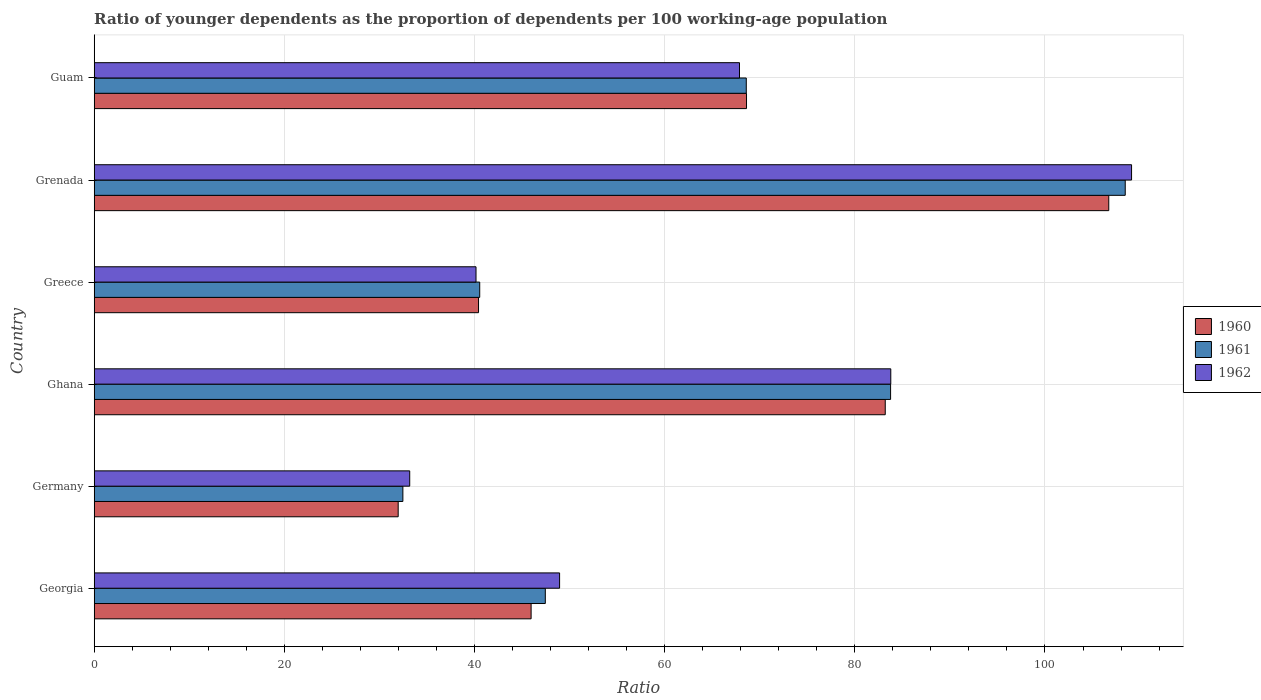How many different coloured bars are there?
Your response must be concise. 3. How many groups of bars are there?
Your answer should be very brief. 6. What is the label of the 6th group of bars from the top?
Offer a terse response. Georgia. What is the age dependency ratio(young) in 1960 in Georgia?
Your response must be concise. 45.95. Across all countries, what is the maximum age dependency ratio(young) in 1961?
Keep it short and to the point. 108.44. Across all countries, what is the minimum age dependency ratio(young) in 1961?
Your response must be concise. 32.47. In which country was the age dependency ratio(young) in 1960 maximum?
Offer a terse response. Grenada. In which country was the age dependency ratio(young) in 1960 minimum?
Your answer should be very brief. Germany. What is the total age dependency ratio(young) in 1962 in the graph?
Your response must be concise. 383.05. What is the difference between the age dependency ratio(young) in 1962 in Ghana and that in Guam?
Ensure brevity in your answer.  15.91. What is the difference between the age dependency ratio(young) in 1962 in Ghana and the age dependency ratio(young) in 1961 in Guam?
Ensure brevity in your answer.  15.2. What is the average age dependency ratio(young) in 1961 per country?
Ensure brevity in your answer.  63.54. What is the difference between the age dependency ratio(young) in 1960 and age dependency ratio(young) in 1961 in Germany?
Give a very brief answer. -0.49. In how many countries, is the age dependency ratio(young) in 1962 greater than 64 ?
Ensure brevity in your answer.  3. What is the ratio of the age dependency ratio(young) in 1961 in Greece to that in Guam?
Your response must be concise. 0.59. Is the age dependency ratio(young) in 1961 in Ghana less than that in Grenada?
Offer a very short reply. Yes. What is the difference between the highest and the second highest age dependency ratio(young) in 1962?
Make the answer very short. 25.32. What is the difference between the highest and the lowest age dependency ratio(young) in 1960?
Offer a terse response. 74.74. Is the sum of the age dependency ratio(young) in 1961 in Georgia and Ghana greater than the maximum age dependency ratio(young) in 1960 across all countries?
Provide a succinct answer. Yes. What does the 3rd bar from the top in Grenada represents?
Keep it short and to the point. 1960. What does the 2nd bar from the bottom in Grenada represents?
Ensure brevity in your answer.  1961. Are all the bars in the graph horizontal?
Give a very brief answer. Yes. How many countries are there in the graph?
Your answer should be compact. 6. Are the values on the major ticks of X-axis written in scientific E-notation?
Offer a terse response. No. Does the graph contain any zero values?
Your answer should be very brief. No. Does the graph contain grids?
Keep it short and to the point. Yes. Where does the legend appear in the graph?
Offer a terse response. Center right. How are the legend labels stacked?
Provide a short and direct response. Vertical. What is the title of the graph?
Make the answer very short. Ratio of younger dependents as the proportion of dependents per 100 working-age population. What is the label or title of the X-axis?
Provide a succinct answer. Ratio. What is the label or title of the Y-axis?
Provide a succinct answer. Country. What is the Ratio of 1960 in Georgia?
Offer a terse response. 45.95. What is the Ratio of 1961 in Georgia?
Give a very brief answer. 47.45. What is the Ratio in 1962 in Georgia?
Your answer should be compact. 48.95. What is the Ratio of 1960 in Germany?
Give a very brief answer. 31.97. What is the Ratio in 1961 in Germany?
Ensure brevity in your answer.  32.47. What is the Ratio of 1962 in Germany?
Give a very brief answer. 33.19. What is the Ratio in 1960 in Ghana?
Your response must be concise. 83.2. What is the Ratio of 1961 in Ghana?
Ensure brevity in your answer.  83.76. What is the Ratio of 1962 in Ghana?
Give a very brief answer. 83.78. What is the Ratio in 1960 in Greece?
Give a very brief answer. 40.42. What is the Ratio of 1961 in Greece?
Offer a very short reply. 40.55. What is the Ratio in 1962 in Greece?
Provide a short and direct response. 40.16. What is the Ratio in 1960 in Grenada?
Your response must be concise. 106.71. What is the Ratio of 1961 in Grenada?
Ensure brevity in your answer.  108.44. What is the Ratio in 1962 in Grenada?
Your answer should be compact. 109.11. What is the Ratio of 1960 in Guam?
Ensure brevity in your answer.  68.61. What is the Ratio in 1961 in Guam?
Give a very brief answer. 68.58. What is the Ratio of 1962 in Guam?
Provide a short and direct response. 67.87. Across all countries, what is the maximum Ratio in 1960?
Provide a succinct answer. 106.71. Across all countries, what is the maximum Ratio in 1961?
Give a very brief answer. 108.44. Across all countries, what is the maximum Ratio in 1962?
Offer a very short reply. 109.11. Across all countries, what is the minimum Ratio in 1960?
Your answer should be compact. 31.97. Across all countries, what is the minimum Ratio in 1961?
Offer a terse response. 32.47. Across all countries, what is the minimum Ratio in 1962?
Make the answer very short. 33.19. What is the total Ratio of 1960 in the graph?
Make the answer very short. 376.86. What is the total Ratio in 1961 in the graph?
Give a very brief answer. 381.24. What is the total Ratio of 1962 in the graph?
Offer a terse response. 383.05. What is the difference between the Ratio in 1960 in Georgia and that in Germany?
Ensure brevity in your answer.  13.98. What is the difference between the Ratio in 1961 in Georgia and that in Germany?
Offer a very short reply. 14.98. What is the difference between the Ratio in 1962 in Georgia and that in Germany?
Provide a succinct answer. 15.76. What is the difference between the Ratio in 1960 in Georgia and that in Ghana?
Make the answer very short. -37.25. What is the difference between the Ratio of 1961 in Georgia and that in Ghana?
Offer a very short reply. -36.32. What is the difference between the Ratio of 1962 in Georgia and that in Ghana?
Provide a short and direct response. -34.83. What is the difference between the Ratio of 1960 in Georgia and that in Greece?
Give a very brief answer. 5.53. What is the difference between the Ratio in 1961 in Georgia and that in Greece?
Your answer should be compact. 6.9. What is the difference between the Ratio of 1962 in Georgia and that in Greece?
Give a very brief answer. 8.79. What is the difference between the Ratio in 1960 in Georgia and that in Grenada?
Offer a very short reply. -60.76. What is the difference between the Ratio of 1961 in Georgia and that in Grenada?
Offer a very short reply. -60.99. What is the difference between the Ratio of 1962 in Georgia and that in Grenada?
Provide a short and direct response. -60.16. What is the difference between the Ratio of 1960 in Georgia and that in Guam?
Keep it short and to the point. -22.66. What is the difference between the Ratio of 1961 in Georgia and that in Guam?
Offer a terse response. -21.14. What is the difference between the Ratio of 1962 in Georgia and that in Guam?
Provide a short and direct response. -18.92. What is the difference between the Ratio in 1960 in Germany and that in Ghana?
Keep it short and to the point. -51.23. What is the difference between the Ratio of 1961 in Germany and that in Ghana?
Offer a very short reply. -51.3. What is the difference between the Ratio in 1962 in Germany and that in Ghana?
Keep it short and to the point. -50.6. What is the difference between the Ratio in 1960 in Germany and that in Greece?
Your answer should be compact. -8.45. What is the difference between the Ratio of 1961 in Germany and that in Greece?
Offer a terse response. -8.08. What is the difference between the Ratio in 1962 in Germany and that in Greece?
Give a very brief answer. -6.97. What is the difference between the Ratio of 1960 in Germany and that in Grenada?
Ensure brevity in your answer.  -74.74. What is the difference between the Ratio of 1961 in Germany and that in Grenada?
Your answer should be compact. -75.97. What is the difference between the Ratio in 1962 in Germany and that in Grenada?
Offer a terse response. -75.92. What is the difference between the Ratio in 1960 in Germany and that in Guam?
Your answer should be very brief. -36.64. What is the difference between the Ratio of 1961 in Germany and that in Guam?
Keep it short and to the point. -36.12. What is the difference between the Ratio of 1962 in Germany and that in Guam?
Keep it short and to the point. -34.69. What is the difference between the Ratio of 1960 in Ghana and that in Greece?
Keep it short and to the point. 42.78. What is the difference between the Ratio of 1961 in Ghana and that in Greece?
Make the answer very short. 43.21. What is the difference between the Ratio of 1962 in Ghana and that in Greece?
Your response must be concise. 43.62. What is the difference between the Ratio of 1960 in Ghana and that in Grenada?
Keep it short and to the point. -23.51. What is the difference between the Ratio in 1961 in Ghana and that in Grenada?
Make the answer very short. -24.68. What is the difference between the Ratio in 1962 in Ghana and that in Grenada?
Offer a terse response. -25.32. What is the difference between the Ratio in 1960 in Ghana and that in Guam?
Your answer should be compact. 14.59. What is the difference between the Ratio in 1961 in Ghana and that in Guam?
Keep it short and to the point. 15.18. What is the difference between the Ratio of 1962 in Ghana and that in Guam?
Keep it short and to the point. 15.91. What is the difference between the Ratio of 1960 in Greece and that in Grenada?
Provide a short and direct response. -66.29. What is the difference between the Ratio in 1961 in Greece and that in Grenada?
Your response must be concise. -67.89. What is the difference between the Ratio of 1962 in Greece and that in Grenada?
Provide a succinct answer. -68.95. What is the difference between the Ratio of 1960 in Greece and that in Guam?
Your answer should be very brief. -28.18. What is the difference between the Ratio of 1961 in Greece and that in Guam?
Your answer should be very brief. -28.04. What is the difference between the Ratio of 1962 in Greece and that in Guam?
Give a very brief answer. -27.71. What is the difference between the Ratio of 1960 in Grenada and that in Guam?
Make the answer very short. 38.1. What is the difference between the Ratio of 1961 in Grenada and that in Guam?
Provide a succinct answer. 39.86. What is the difference between the Ratio of 1962 in Grenada and that in Guam?
Offer a terse response. 41.23. What is the difference between the Ratio in 1960 in Georgia and the Ratio in 1961 in Germany?
Offer a very short reply. 13.49. What is the difference between the Ratio of 1960 in Georgia and the Ratio of 1962 in Germany?
Give a very brief answer. 12.77. What is the difference between the Ratio in 1961 in Georgia and the Ratio in 1962 in Germany?
Your answer should be very brief. 14.26. What is the difference between the Ratio of 1960 in Georgia and the Ratio of 1961 in Ghana?
Your response must be concise. -37.81. What is the difference between the Ratio in 1960 in Georgia and the Ratio in 1962 in Ghana?
Give a very brief answer. -37.83. What is the difference between the Ratio in 1961 in Georgia and the Ratio in 1962 in Ghana?
Provide a succinct answer. -36.34. What is the difference between the Ratio of 1960 in Georgia and the Ratio of 1961 in Greece?
Your answer should be compact. 5.41. What is the difference between the Ratio of 1960 in Georgia and the Ratio of 1962 in Greece?
Ensure brevity in your answer.  5.79. What is the difference between the Ratio in 1961 in Georgia and the Ratio in 1962 in Greece?
Provide a short and direct response. 7.29. What is the difference between the Ratio in 1960 in Georgia and the Ratio in 1961 in Grenada?
Your answer should be compact. -62.49. What is the difference between the Ratio in 1960 in Georgia and the Ratio in 1962 in Grenada?
Offer a terse response. -63.15. What is the difference between the Ratio in 1961 in Georgia and the Ratio in 1962 in Grenada?
Your answer should be compact. -61.66. What is the difference between the Ratio of 1960 in Georgia and the Ratio of 1961 in Guam?
Your answer should be very brief. -22.63. What is the difference between the Ratio in 1960 in Georgia and the Ratio in 1962 in Guam?
Provide a succinct answer. -21.92. What is the difference between the Ratio of 1961 in Georgia and the Ratio of 1962 in Guam?
Provide a succinct answer. -20.42. What is the difference between the Ratio in 1960 in Germany and the Ratio in 1961 in Ghana?
Provide a short and direct response. -51.79. What is the difference between the Ratio of 1960 in Germany and the Ratio of 1962 in Ghana?
Your answer should be very brief. -51.81. What is the difference between the Ratio in 1961 in Germany and the Ratio in 1962 in Ghana?
Ensure brevity in your answer.  -51.32. What is the difference between the Ratio of 1960 in Germany and the Ratio of 1961 in Greece?
Provide a short and direct response. -8.57. What is the difference between the Ratio of 1960 in Germany and the Ratio of 1962 in Greece?
Offer a terse response. -8.19. What is the difference between the Ratio in 1961 in Germany and the Ratio in 1962 in Greece?
Offer a very short reply. -7.69. What is the difference between the Ratio in 1960 in Germany and the Ratio in 1961 in Grenada?
Provide a succinct answer. -76.47. What is the difference between the Ratio of 1960 in Germany and the Ratio of 1962 in Grenada?
Your response must be concise. -77.13. What is the difference between the Ratio of 1961 in Germany and the Ratio of 1962 in Grenada?
Make the answer very short. -76.64. What is the difference between the Ratio in 1960 in Germany and the Ratio in 1961 in Guam?
Provide a succinct answer. -36.61. What is the difference between the Ratio of 1960 in Germany and the Ratio of 1962 in Guam?
Your response must be concise. -35.9. What is the difference between the Ratio of 1961 in Germany and the Ratio of 1962 in Guam?
Your response must be concise. -35.41. What is the difference between the Ratio in 1960 in Ghana and the Ratio in 1961 in Greece?
Ensure brevity in your answer.  42.65. What is the difference between the Ratio in 1960 in Ghana and the Ratio in 1962 in Greece?
Your answer should be compact. 43.04. What is the difference between the Ratio of 1961 in Ghana and the Ratio of 1962 in Greece?
Keep it short and to the point. 43.6. What is the difference between the Ratio in 1960 in Ghana and the Ratio in 1961 in Grenada?
Make the answer very short. -25.24. What is the difference between the Ratio of 1960 in Ghana and the Ratio of 1962 in Grenada?
Your answer should be compact. -25.91. What is the difference between the Ratio of 1961 in Ghana and the Ratio of 1962 in Grenada?
Offer a very short reply. -25.34. What is the difference between the Ratio in 1960 in Ghana and the Ratio in 1961 in Guam?
Provide a succinct answer. 14.62. What is the difference between the Ratio of 1960 in Ghana and the Ratio of 1962 in Guam?
Your response must be concise. 15.33. What is the difference between the Ratio of 1961 in Ghana and the Ratio of 1962 in Guam?
Your answer should be very brief. 15.89. What is the difference between the Ratio of 1960 in Greece and the Ratio of 1961 in Grenada?
Provide a short and direct response. -68.02. What is the difference between the Ratio of 1960 in Greece and the Ratio of 1962 in Grenada?
Your answer should be compact. -68.68. What is the difference between the Ratio of 1961 in Greece and the Ratio of 1962 in Grenada?
Your response must be concise. -68.56. What is the difference between the Ratio in 1960 in Greece and the Ratio in 1961 in Guam?
Give a very brief answer. -28.16. What is the difference between the Ratio of 1960 in Greece and the Ratio of 1962 in Guam?
Offer a terse response. -27.45. What is the difference between the Ratio in 1961 in Greece and the Ratio in 1962 in Guam?
Ensure brevity in your answer.  -27.32. What is the difference between the Ratio of 1960 in Grenada and the Ratio of 1961 in Guam?
Your answer should be very brief. 38.13. What is the difference between the Ratio in 1960 in Grenada and the Ratio in 1962 in Guam?
Your answer should be very brief. 38.84. What is the difference between the Ratio in 1961 in Grenada and the Ratio in 1962 in Guam?
Make the answer very short. 40.57. What is the average Ratio of 1960 per country?
Ensure brevity in your answer.  62.81. What is the average Ratio in 1961 per country?
Your answer should be compact. 63.54. What is the average Ratio in 1962 per country?
Offer a very short reply. 63.84. What is the difference between the Ratio of 1960 and Ratio of 1961 in Georgia?
Your answer should be compact. -1.49. What is the difference between the Ratio of 1960 and Ratio of 1962 in Georgia?
Your answer should be very brief. -3. What is the difference between the Ratio of 1961 and Ratio of 1962 in Georgia?
Keep it short and to the point. -1.5. What is the difference between the Ratio of 1960 and Ratio of 1961 in Germany?
Offer a very short reply. -0.49. What is the difference between the Ratio in 1960 and Ratio in 1962 in Germany?
Make the answer very short. -1.21. What is the difference between the Ratio in 1961 and Ratio in 1962 in Germany?
Give a very brief answer. -0.72. What is the difference between the Ratio in 1960 and Ratio in 1961 in Ghana?
Offer a terse response. -0.56. What is the difference between the Ratio in 1960 and Ratio in 1962 in Ghana?
Offer a very short reply. -0.58. What is the difference between the Ratio of 1961 and Ratio of 1962 in Ghana?
Your answer should be very brief. -0.02. What is the difference between the Ratio in 1960 and Ratio in 1961 in Greece?
Ensure brevity in your answer.  -0.12. What is the difference between the Ratio of 1960 and Ratio of 1962 in Greece?
Keep it short and to the point. 0.26. What is the difference between the Ratio of 1961 and Ratio of 1962 in Greece?
Provide a succinct answer. 0.39. What is the difference between the Ratio of 1960 and Ratio of 1961 in Grenada?
Your response must be concise. -1.73. What is the difference between the Ratio of 1960 and Ratio of 1962 in Grenada?
Provide a short and direct response. -2.4. What is the difference between the Ratio of 1961 and Ratio of 1962 in Grenada?
Your answer should be very brief. -0.67. What is the difference between the Ratio in 1960 and Ratio in 1961 in Guam?
Offer a terse response. 0.02. What is the difference between the Ratio in 1960 and Ratio in 1962 in Guam?
Your answer should be compact. 0.74. What is the difference between the Ratio in 1961 and Ratio in 1962 in Guam?
Provide a short and direct response. 0.71. What is the ratio of the Ratio of 1960 in Georgia to that in Germany?
Provide a succinct answer. 1.44. What is the ratio of the Ratio in 1961 in Georgia to that in Germany?
Offer a very short reply. 1.46. What is the ratio of the Ratio of 1962 in Georgia to that in Germany?
Your answer should be very brief. 1.48. What is the ratio of the Ratio of 1960 in Georgia to that in Ghana?
Give a very brief answer. 0.55. What is the ratio of the Ratio in 1961 in Georgia to that in Ghana?
Provide a succinct answer. 0.57. What is the ratio of the Ratio of 1962 in Georgia to that in Ghana?
Give a very brief answer. 0.58. What is the ratio of the Ratio of 1960 in Georgia to that in Greece?
Ensure brevity in your answer.  1.14. What is the ratio of the Ratio of 1961 in Georgia to that in Greece?
Give a very brief answer. 1.17. What is the ratio of the Ratio in 1962 in Georgia to that in Greece?
Provide a succinct answer. 1.22. What is the ratio of the Ratio in 1960 in Georgia to that in Grenada?
Your response must be concise. 0.43. What is the ratio of the Ratio in 1961 in Georgia to that in Grenada?
Provide a succinct answer. 0.44. What is the ratio of the Ratio in 1962 in Georgia to that in Grenada?
Your answer should be very brief. 0.45. What is the ratio of the Ratio of 1960 in Georgia to that in Guam?
Keep it short and to the point. 0.67. What is the ratio of the Ratio of 1961 in Georgia to that in Guam?
Provide a short and direct response. 0.69. What is the ratio of the Ratio in 1962 in Georgia to that in Guam?
Provide a short and direct response. 0.72. What is the ratio of the Ratio in 1960 in Germany to that in Ghana?
Provide a succinct answer. 0.38. What is the ratio of the Ratio in 1961 in Germany to that in Ghana?
Your answer should be compact. 0.39. What is the ratio of the Ratio of 1962 in Germany to that in Ghana?
Make the answer very short. 0.4. What is the ratio of the Ratio in 1960 in Germany to that in Greece?
Ensure brevity in your answer.  0.79. What is the ratio of the Ratio in 1961 in Germany to that in Greece?
Provide a succinct answer. 0.8. What is the ratio of the Ratio of 1962 in Germany to that in Greece?
Your response must be concise. 0.83. What is the ratio of the Ratio of 1960 in Germany to that in Grenada?
Make the answer very short. 0.3. What is the ratio of the Ratio of 1961 in Germany to that in Grenada?
Offer a very short reply. 0.3. What is the ratio of the Ratio of 1962 in Germany to that in Grenada?
Provide a succinct answer. 0.3. What is the ratio of the Ratio of 1960 in Germany to that in Guam?
Your answer should be very brief. 0.47. What is the ratio of the Ratio in 1961 in Germany to that in Guam?
Keep it short and to the point. 0.47. What is the ratio of the Ratio in 1962 in Germany to that in Guam?
Ensure brevity in your answer.  0.49. What is the ratio of the Ratio in 1960 in Ghana to that in Greece?
Your response must be concise. 2.06. What is the ratio of the Ratio of 1961 in Ghana to that in Greece?
Make the answer very short. 2.07. What is the ratio of the Ratio in 1962 in Ghana to that in Greece?
Provide a short and direct response. 2.09. What is the ratio of the Ratio of 1960 in Ghana to that in Grenada?
Make the answer very short. 0.78. What is the ratio of the Ratio in 1961 in Ghana to that in Grenada?
Your answer should be very brief. 0.77. What is the ratio of the Ratio in 1962 in Ghana to that in Grenada?
Provide a succinct answer. 0.77. What is the ratio of the Ratio of 1960 in Ghana to that in Guam?
Keep it short and to the point. 1.21. What is the ratio of the Ratio of 1961 in Ghana to that in Guam?
Your answer should be very brief. 1.22. What is the ratio of the Ratio in 1962 in Ghana to that in Guam?
Offer a very short reply. 1.23. What is the ratio of the Ratio in 1960 in Greece to that in Grenada?
Provide a short and direct response. 0.38. What is the ratio of the Ratio in 1961 in Greece to that in Grenada?
Give a very brief answer. 0.37. What is the ratio of the Ratio of 1962 in Greece to that in Grenada?
Make the answer very short. 0.37. What is the ratio of the Ratio in 1960 in Greece to that in Guam?
Offer a terse response. 0.59. What is the ratio of the Ratio in 1961 in Greece to that in Guam?
Provide a succinct answer. 0.59. What is the ratio of the Ratio of 1962 in Greece to that in Guam?
Offer a very short reply. 0.59. What is the ratio of the Ratio in 1960 in Grenada to that in Guam?
Offer a very short reply. 1.56. What is the ratio of the Ratio of 1961 in Grenada to that in Guam?
Make the answer very short. 1.58. What is the ratio of the Ratio in 1962 in Grenada to that in Guam?
Make the answer very short. 1.61. What is the difference between the highest and the second highest Ratio of 1960?
Make the answer very short. 23.51. What is the difference between the highest and the second highest Ratio in 1961?
Ensure brevity in your answer.  24.68. What is the difference between the highest and the second highest Ratio of 1962?
Offer a terse response. 25.32. What is the difference between the highest and the lowest Ratio in 1960?
Keep it short and to the point. 74.74. What is the difference between the highest and the lowest Ratio of 1961?
Offer a terse response. 75.97. What is the difference between the highest and the lowest Ratio of 1962?
Your answer should be compact. 75.92. 